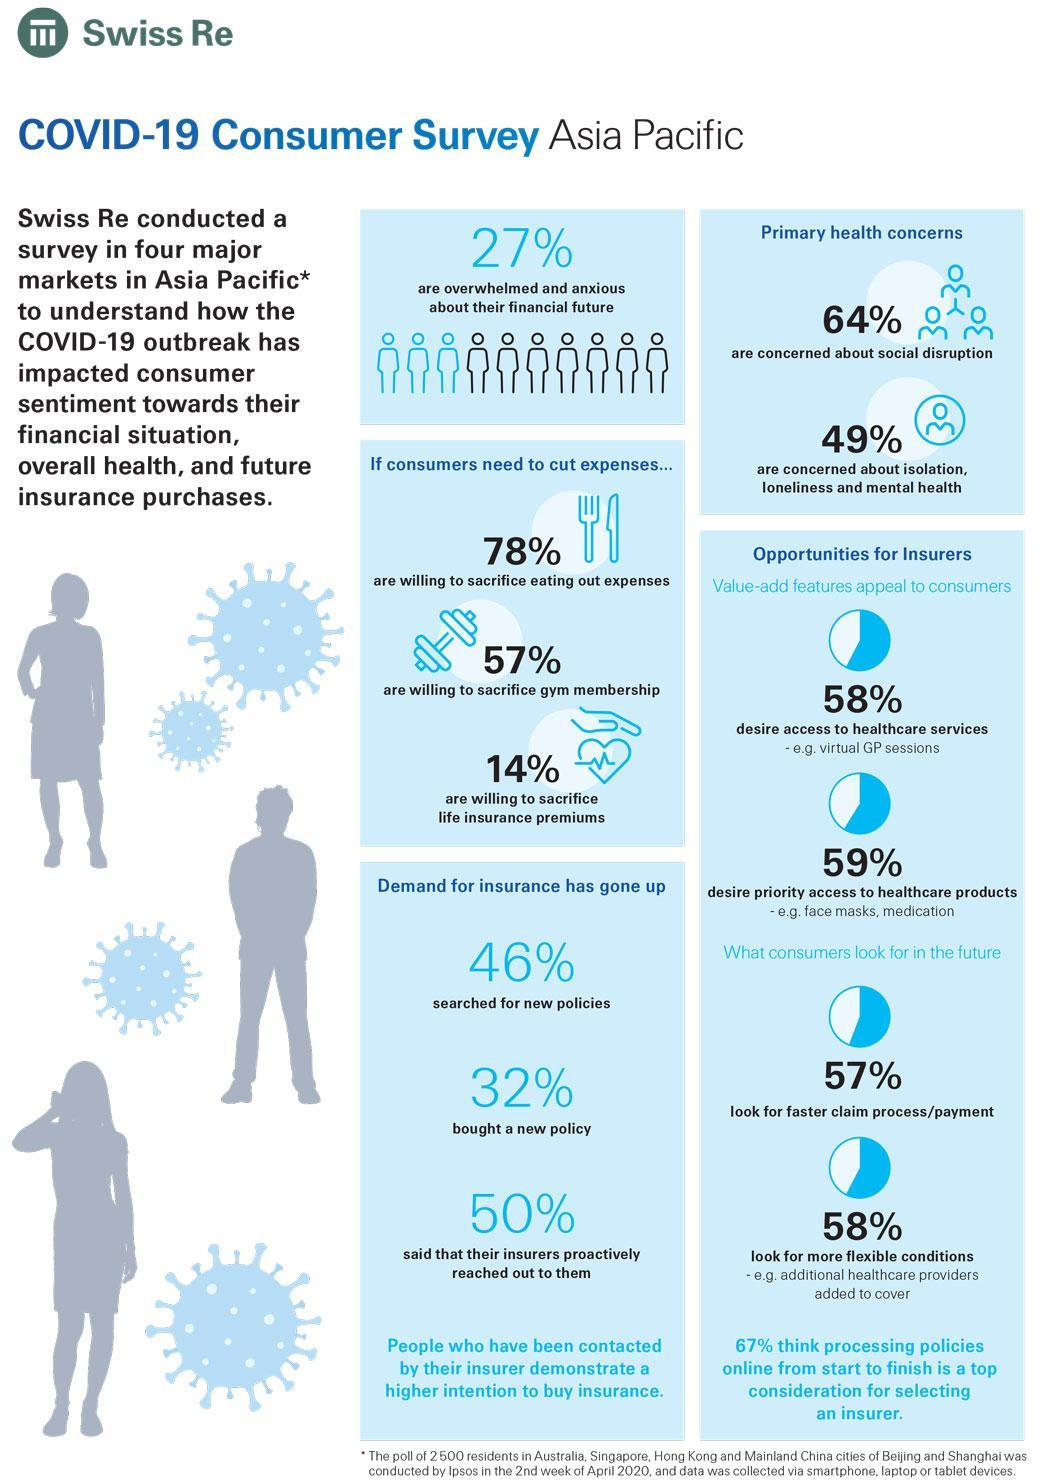What percentage of consumers bought a new policy as per the survey conducted in Asia Pacific?
Answer the question with a short phrase. 32% What percentage of consumers are not willing to sacrifice the life insurance premiums if they need to cut down the expenses as per the survey conducted in Asia Pacific? 86% What percentage of consumers are willing to sacrifice gym membership if they need to cut down the expenses as per the survey conducted in Asia Pacific? 57% What percentage of consumers searched for new policies as per the survey conducted in Asia Pacific? 46% What percentage of consumers are not concerned about the social disruption as per the survey conducted in Asia Pacific? 36% 